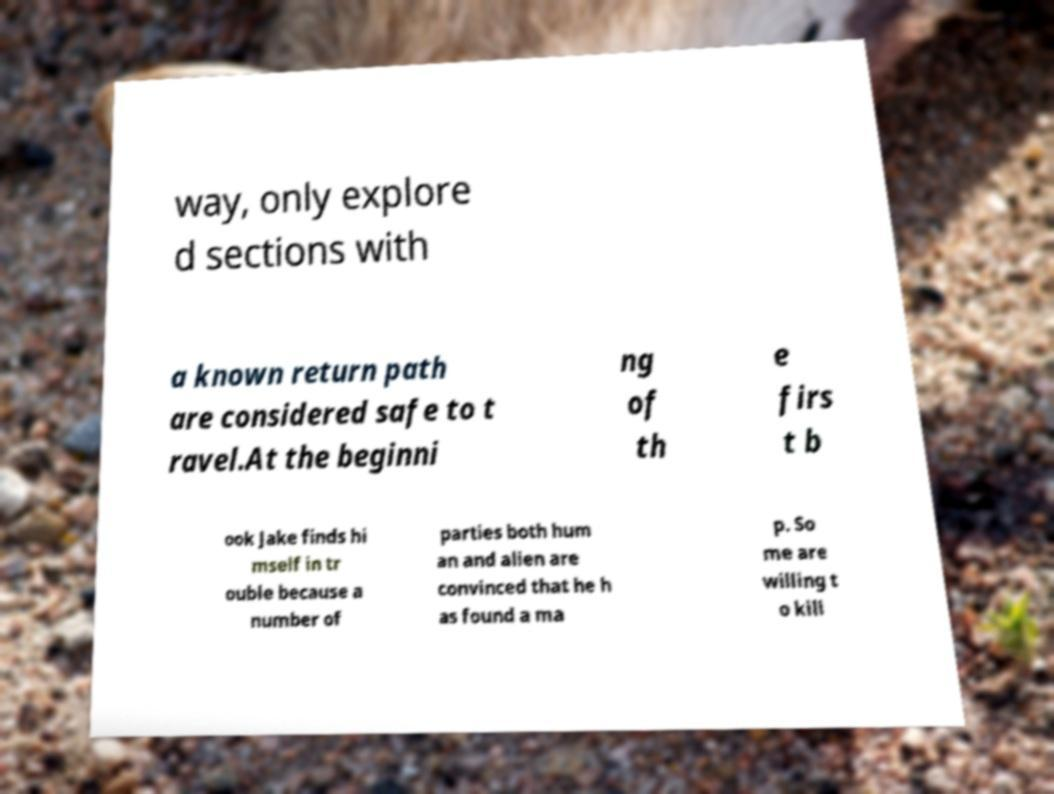For documentation purposes, I need the text within this image transcribed. Could you provide that? way, only explore d sections with a known return path are considered safe to t ravel.At the beginni ng of th e firs t b ook Jake finds hi mself in tr ouble because a number of parties both hum an and alien are convinced that he h as found a ma p. So me are willing t o kill 